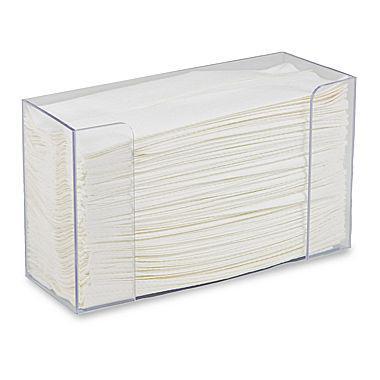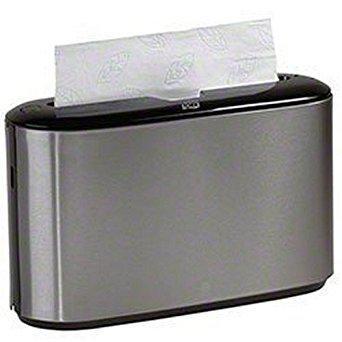The first image is the image on the left, the second image is the image on the right. For the images shown, is this caption "Different style holders are shown in the left and right images, and the right image features an upright oblong opaque holder with a paper towel sticking out of its top." true? Answer yes or no. Yes. The first image is the image on the left, the second image is the image on the right. Analyze the images presented: Is the assertion "A paper is poking out of the dispenser in the image on the right." valid? Answer yes or no. Yes. 